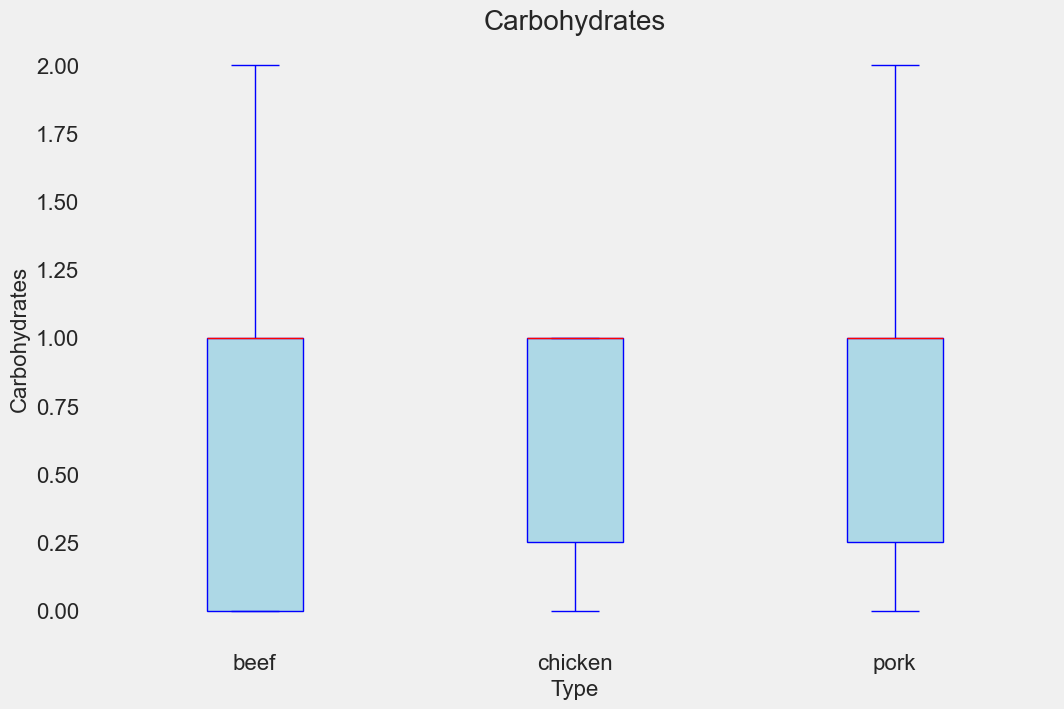Which type of barbecue food generally contains the highest calories? The box plot will show the different distributions of calories for beef, pork, and chicken. By comparing the medians (red lines) and the interquartile ranges (IQR), it will be evident which type has the higher central tendency and overall higher caloric values.
Answer: Beef Which type of meat has the least variation in protein content? Variation in a box plot is represented by the length of the box and the whiskers. The type with the shortest box and whiskers for protein content has the least variation.
Answer: Chicken How do the fat contents of pork and chicken compare? By comparing the boxes and median lines for pork and chicken, one can see which has a higher central value and whether any outliers affect the comparison.
Answer: Pork generally has more fat than chicken What's the average of the median protein content for all three types of meat? First, identify the median protein content for beef, pork, and chicken from the plots. Add these three medians together and divide by 3 to find the average.
Answer: (28+24+23.5)/3 = 25.17 Which type of barbecue food has the highest median carbohydrates content? The box plot's red lines indicate the median values. By comparing these lines for carbohydrate content across the types, the highest can be identified.
Answer: Beef Is there a type of barbecue food that doesn't contain any carbohydrates? Look for any box plots where the entire box and whiskers are at zero for carbohydrates.
Answer: No Which protein content is more variable, beef or pork? Compare the range between the whiskers (longer whiskers indicate more variability) and the size of the boxes between beef and pork for protein content.
Answer: Pork How do the calorie contents of beef and chicken compare visually? By looking at the range, medians, and interquartile ranges, determine which group generally has higher or broader values.
Answer: Beef generally has higher calories than chicken Do all types of barbecue food have similar ranges for fat content? Check the length of the boxes and the whiskers to see if the ranges overlap significantly or if there's a type that stands out.
Answer: No What's the median value for carbohydrates in pork? Look at the red line in the boxes for pork in the carbohydrate plot.
Answer: 1 